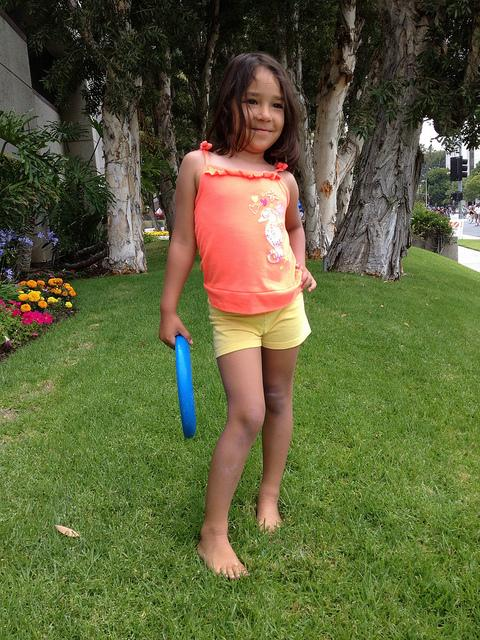The girl is positioning her body in the way a model does by doing what? posing 